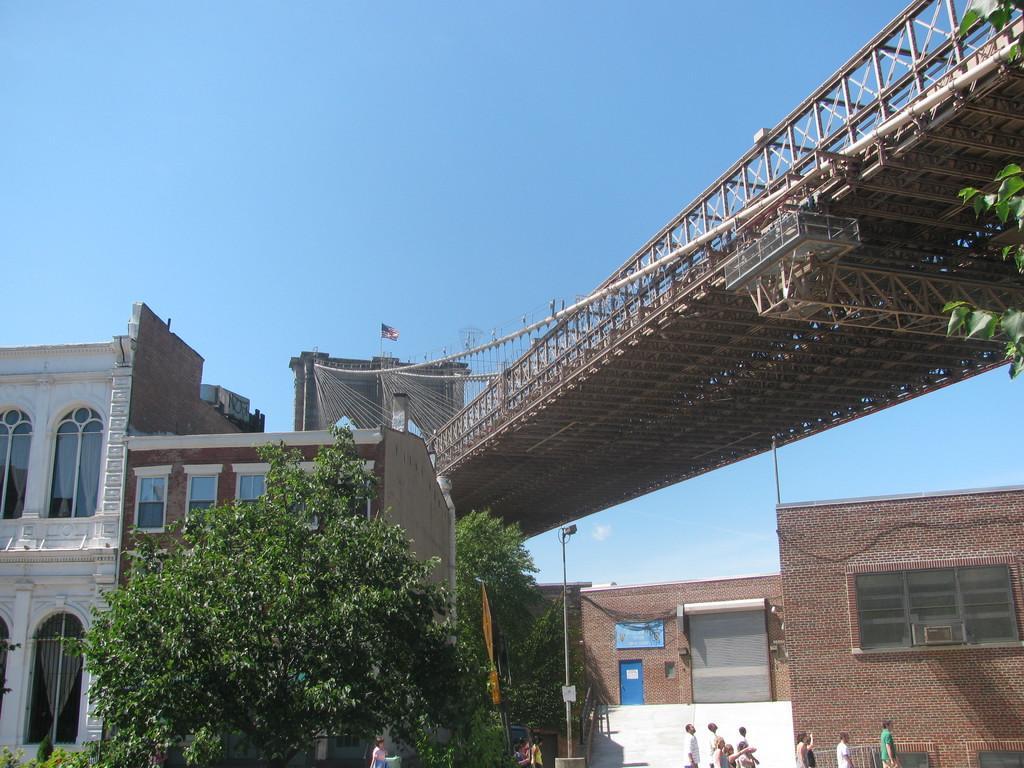Please provide a concise description of this image. In the foreground of the picture there are trees, streetlight, plants and people. In the center of the picture there are bridge and buildings. At the top it is sky. 